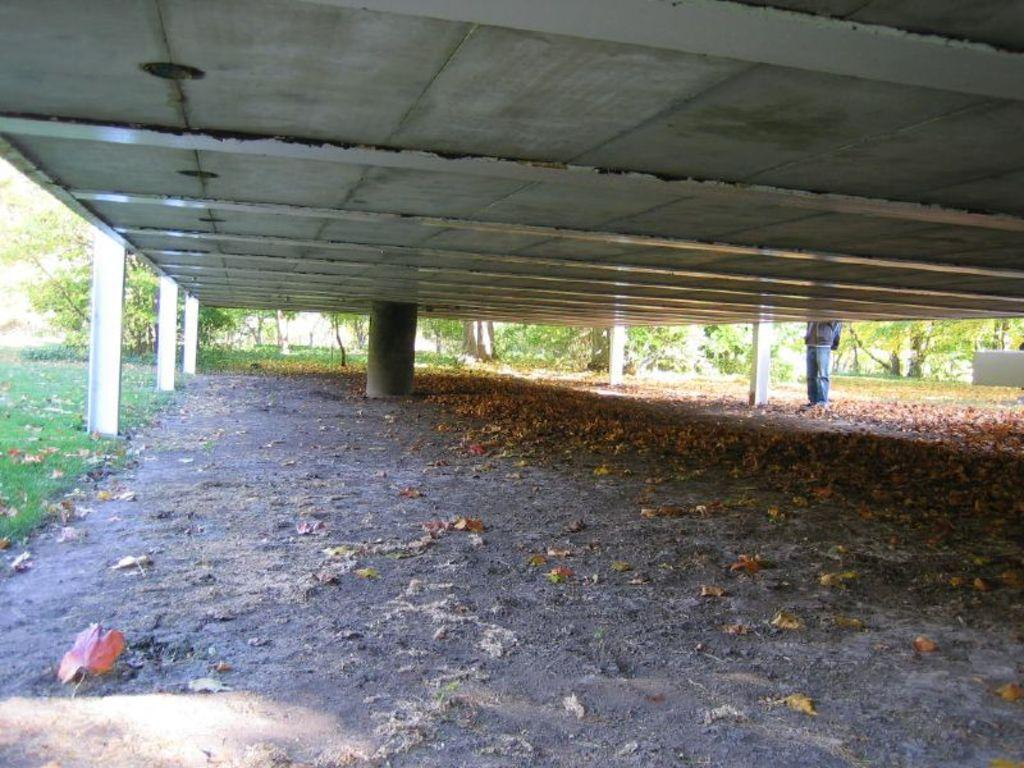What type of surface can be seen in the image? Ground is visible in the image. What is present on the ground? There are leaves on the ground. What architectural feature is in the image? There is a pillar in the image. What part of a building is visible in the image? The ceiling is visible in the image. What type of vegetation is present in the image? There is grass in the image. Can you describe the person in the image? There is a person standing in the image. What can be seen in the background of the image? There are trees in the background of the image. How many women are in prison in the image? There are no women or prison present in the image. What type of flame can be seen coming from the person's hand in the image? There is no flame present in the image; the person is not holding or producing any fire. 